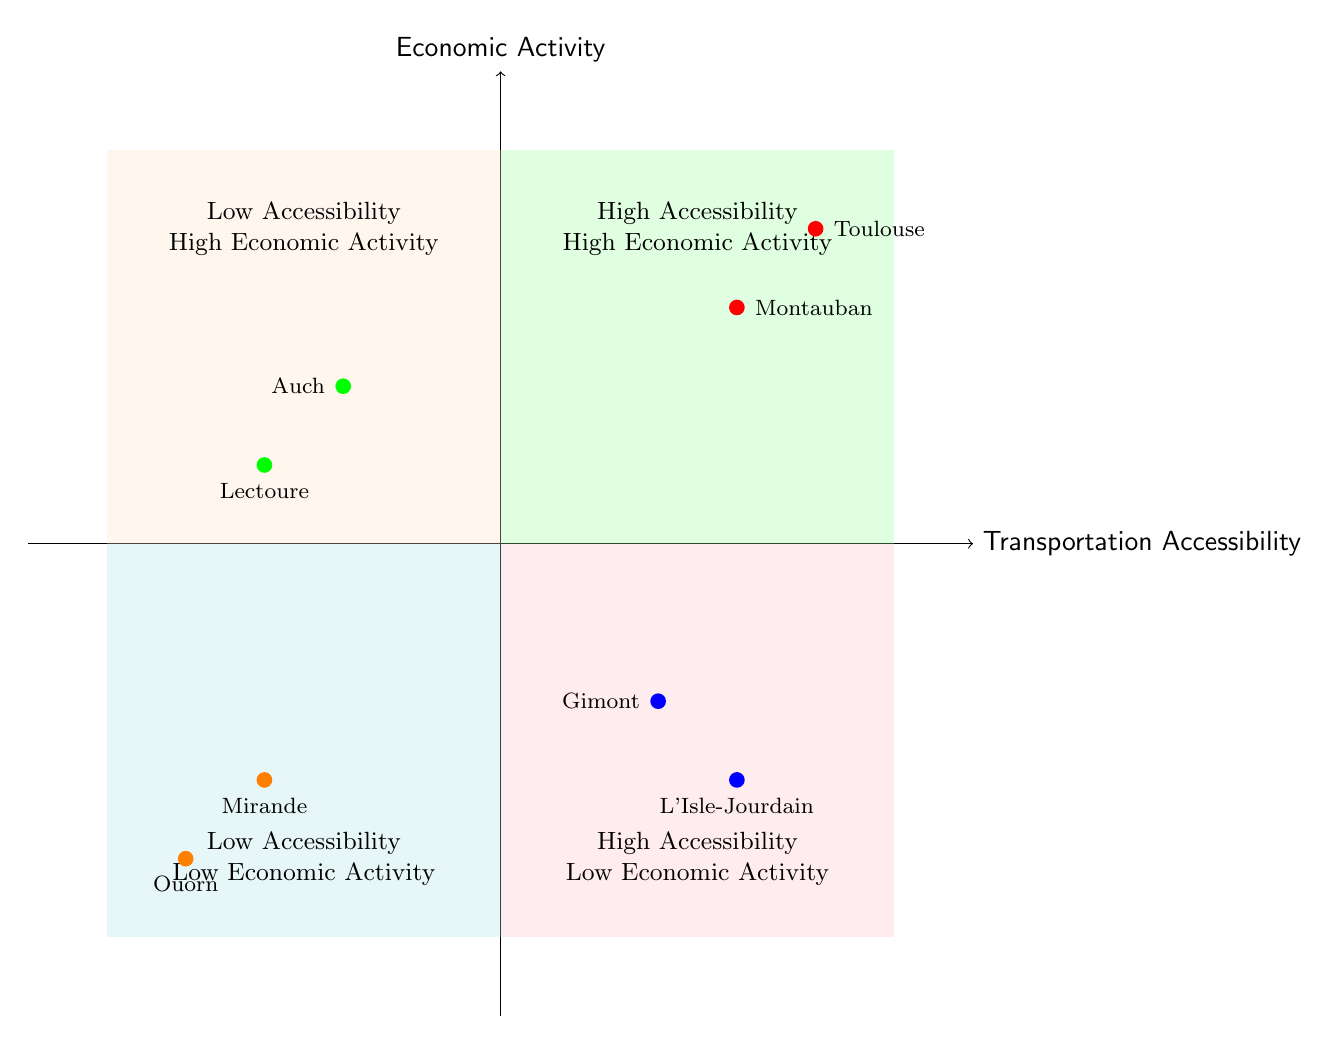What cities have high accessibility and high economic activity? The quadrant for high accessibility and high economic activity shows Toulouse and Montauban as examples. Therefore, these two cities fall into this quadrant.
Answer: Toulouse, Montauban Which city is in the low accessibility and high economic activity quadrant? The low accessibility and high economic activity quadrant contains Auch and Lectoure, but only one city is asked for; therefore, Auch answers the question directly.
Answer: Auch How many cities are in the high accessibility and low economic activity quadrant? This quadrant includes Gimont and L'Isle-Jourdain, which total two cities. Thus, the number of cities here is simply counted from the examples given.
Answer: 2 What type of economic activity does Mirande focus on? Mirande is described as a remote rural area focused on agriculture. Only the description of Mirande provides the type of economic activity, which specifies agriculture as the main focus.
Answer: Agriculture Which city serves primarily as a commuter town? The city of L'Isle-Jourdain is indicated as serving mainly as a commuter town in the description provided. Therefore, it is the city that fits this role.
Answer: L'Isle-Jourdain Which cities are examples of both low accessibility and low economic activity? The low accessibility and low economic activity quadrant shows Mirande and Ouorn as examples. Each city is provided for the quadrant, which indicates both categories.
Answer: Mirande, Ouorn Is Montauban more economically active than Gimont? Montauban is in the high accessibility and high economic activity quadrant, while Gimont is in the high accessibility and low economic activity quadrant, indicating Montauban has higher economic activity than Gimont based on their respective quadrants.
Answer: Yes Which quadrant contains cities with better transportation access but less economic activity? The quadrant with high accessibility but low economic activity contains Gimont and L'Isle-Jourdain. This directly answers the query regarding transportation access relative to the economic activity depicted.
Answer: High Accessibility - Low Economic Activity What is the primary focus of Lectoure's economy? Lectoure focuses on agritourism and heritage tourism despite having limited transportation links, as stated in its description. This highlights the economic activities in which Lectoure is involved.
Answer: Agritourism, Heritage tourism 